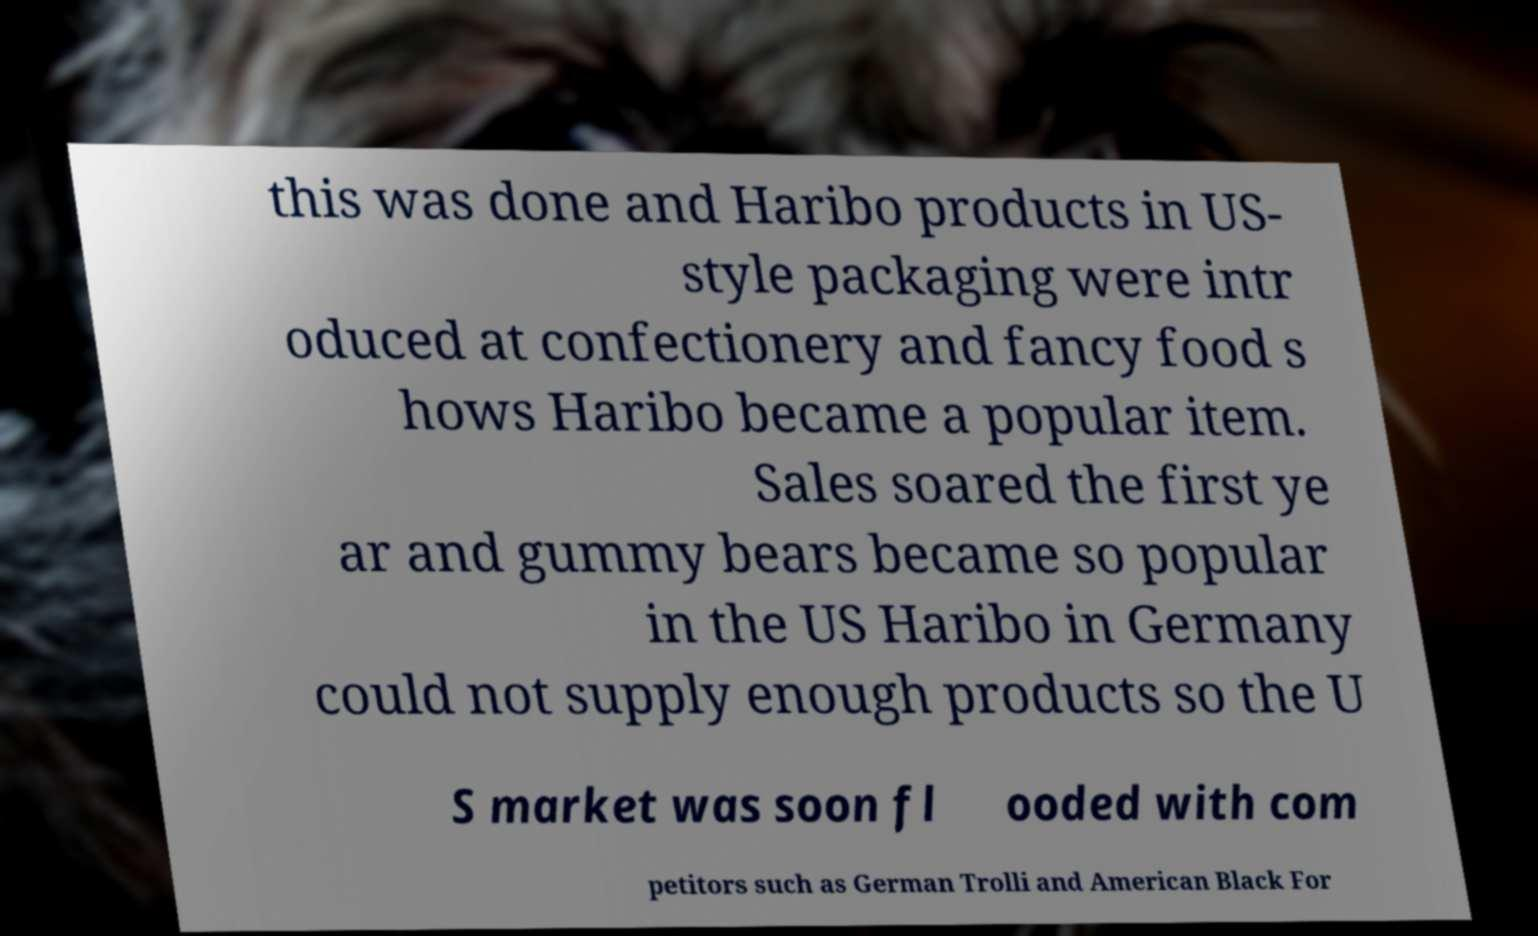Please identify and transcribe the text found in this image. this was done and Haribo products in US- style packaging were intr oduced at confectionery and fancy food s hows Haribo became a popular item. Sales soared the first ye ar and gummy bears became so popular in the US Haribo in Germany could not supply enough products so the U S market was soon fl ooded with com petitors such as German Trolli and American Black For 